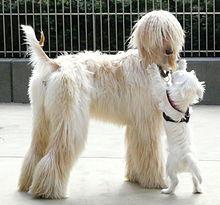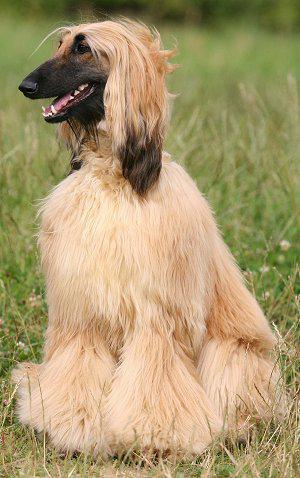The first image is the image on the left, the second image is the image on the right. Assess this claim about the two images: "There is more than one dog in one of the images.". Correct or not? Answer yes or no. Yes. 